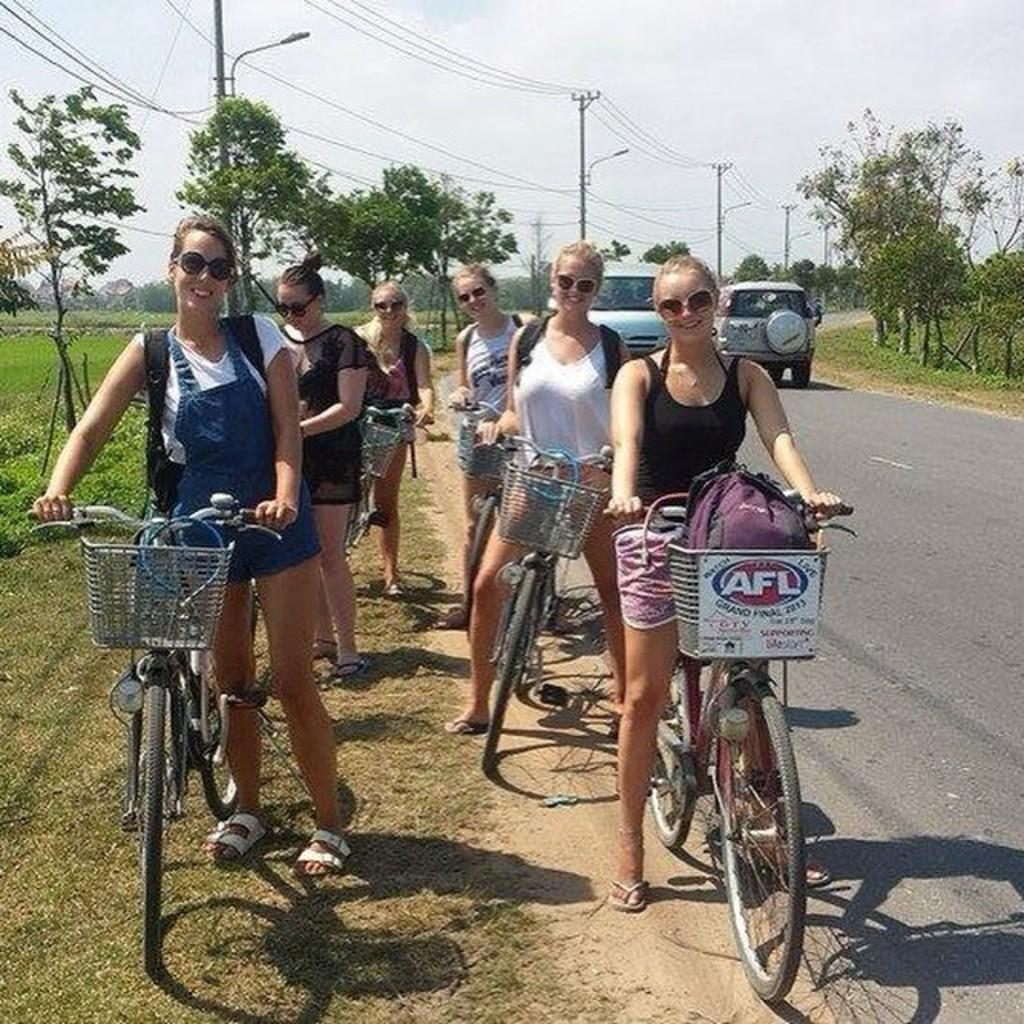How many girls are present in the image? There are six girls in the picture. What are the girls wearing in the image? The girls are wearing goggles in the image. What can be seen besides the girls in the image? There are bicycles, a vehicle, an electric pole, and many trees around in the image. What is the color of the sky in the image? The sky is white in the image. What type of shirt is the girl wearing in the image? There is no specific shirt mentioned in the facts provided, and the girls are wearing goggles, not shirts. --- Facts: 1. There is a person holding a book in the image. 2. The book has a blue cover. 3. The person is sitting on a chair. 4. There is a table in the image. 5. The table has a lamp on it. 6. There is a window in the image. Absurd Topics: dance, ocean, bird Conversation: What is the person in the image holding? The person in the image is holding a book. What color is the book's cover? The book has a blue cover. Where is the person sitting in the image? The person is sitting on a chair. What else can be seen in the image besides the person and the book? There is a table, a lamp on the table, and a window in the image. Reasoning: Let's think step by step in order to produce the conversation. We start by identifying the main subject in the image, which is the person holding a book. Then, we expand the conversation to include other items that are also visible, such as the book's color, the chair, the table, the lamp, and the window. Each question is designed to elicit a specific detail about the image that is known from the provided facts. Absurd Question/Answer: Can you see any ocean waves in the image? There is no mention of an ocean or waves in the facts provided, and the image does not depict any such scene. 